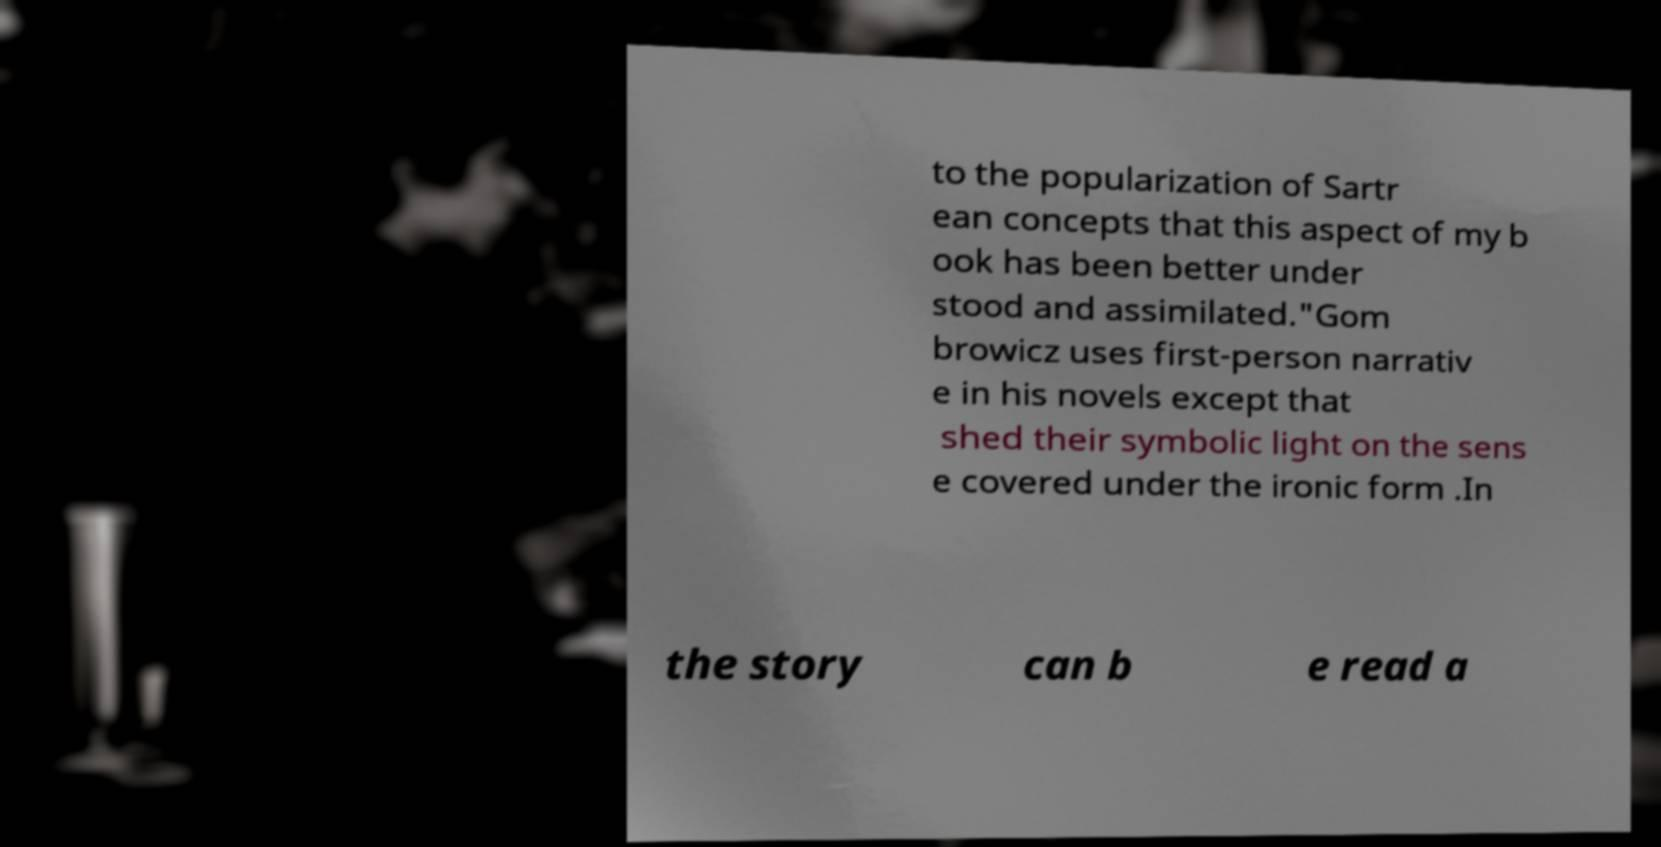For documentation purposes, I need the text within this image transcribed. Could you provide that? to the popularization of Sartr ean concepts that this aspect of my b ook has been better under stood and assimilated."Gom browicz uses first-person narrativ e in his novels except that shed their symbolic light on the sens e covered under the ironic form .In the story can b e read a 